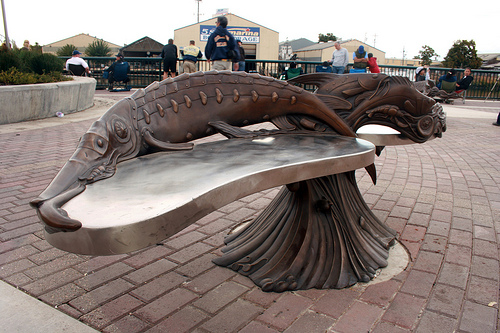<image>
Is there a fish on the table? Yes. Looking at the image, I can see the fish is positioned on top of the table, with the table providing support. 